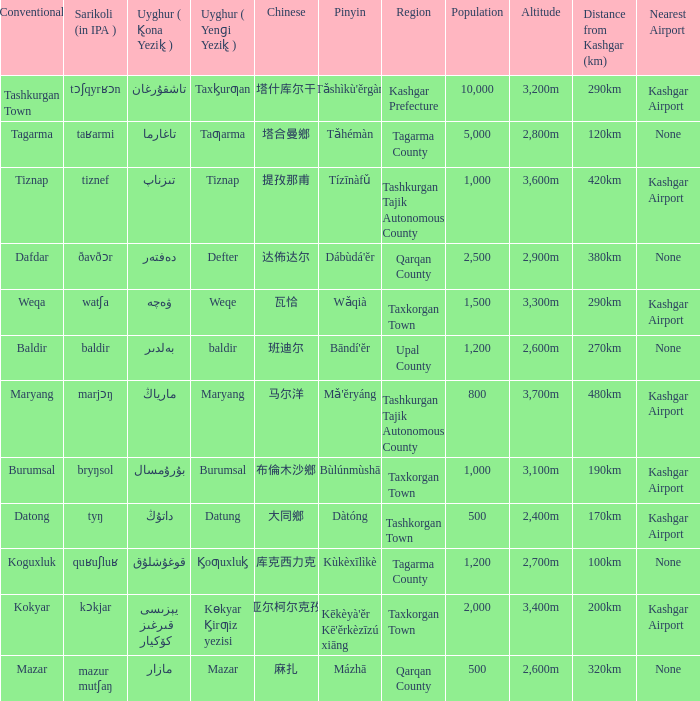Name the conventional for defter Dafdar. 